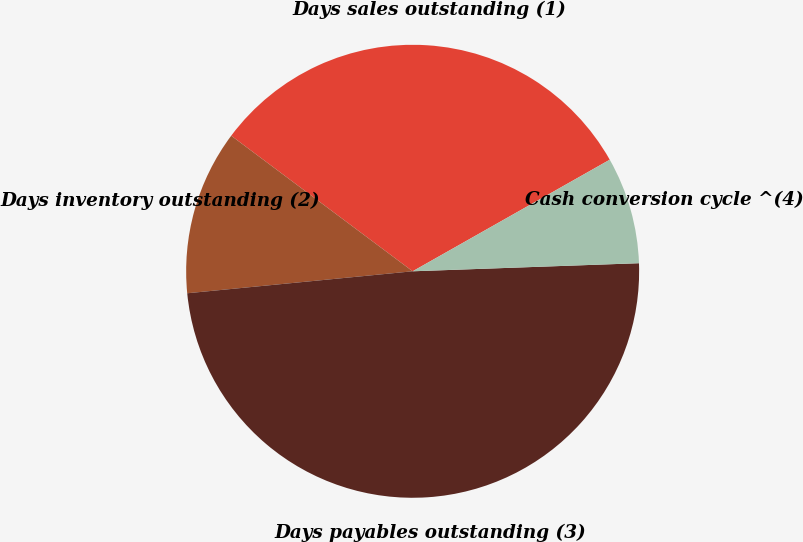Convert chart. <chart><loc_0><loc_0><loc_500><loc_500><pie_chart><fcel>Days sales outstanding (1)<fcel>Days inventory outstanding (2)<fcel>Days payables outstanding (3)<fcel>Cash conversion cycle ^(4)<nl><fcel>31.59%<fcel>11.76%<fcel>49.02%<fcel>7.63%<nl></chart> 